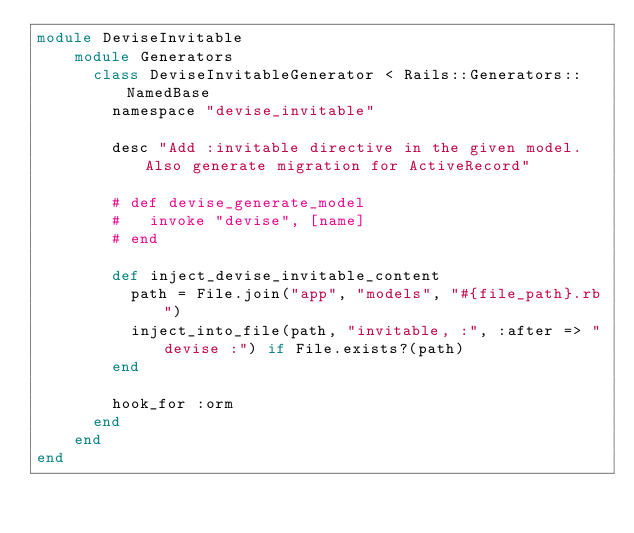<code> <loc_0><loc_0><loc_500><loc_500><_Ruby_>module DeviseInvitable
    module Generators
      class DeviseInvitableGenerator < Rails::Generators::NamedBase
        namespace "devise_invitable"
  
        desc "Add :invitable directive in the given model. Also generate migration for ActiveRecord"
  
        # def devise_generate_model
        #   invoke "devise", [name]
        # end
  
        def inject_devise_invitable_content
          path = File.join("app", "models", "#{file_path}.rb")
          inject_into_file(path, "invitable, :", :after => "devise :") if File.exists?(path)
        end
  
        hook_for :orm
      end
    end
end</code> 